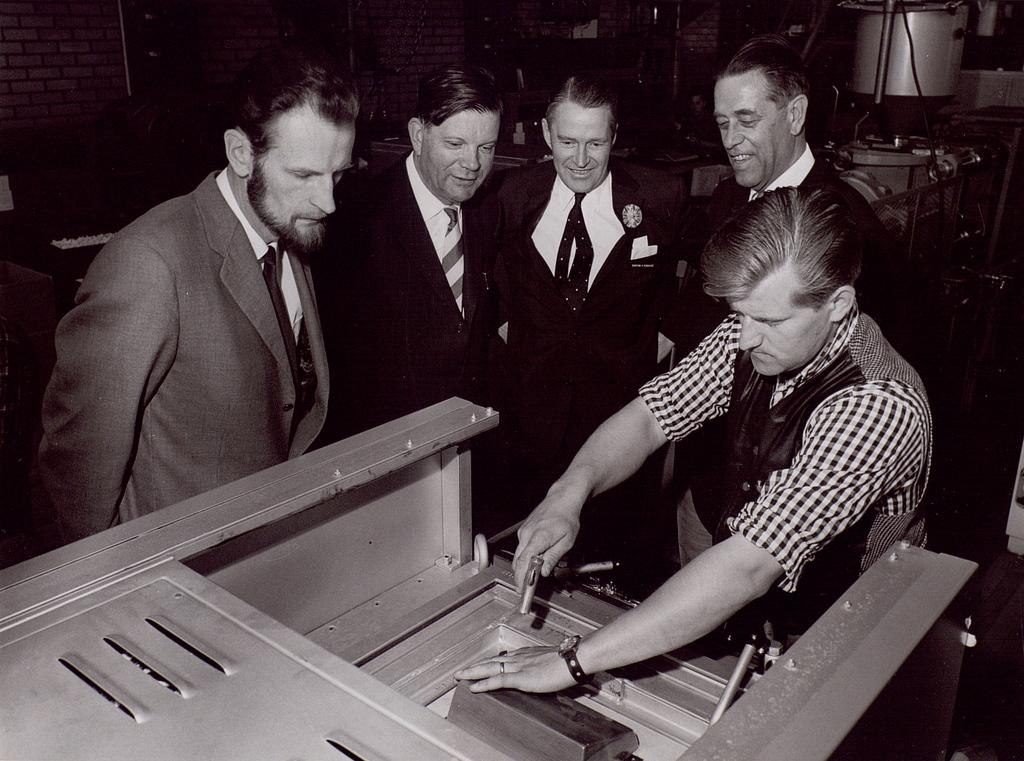What is located at the bottom of the image? There may be a machine at the bottom of the image. What is in front of the machine at the bottom of the image? There are people in front of the machine. What else can be seen on the right side of the image? There is another machine on the right side of the image, behind the people. What type of book is being read by the people in the image? There is no book present in the image; it features people in front of a machine. How many stockings are visible on the people in the image? There is no mention of stockings in the image; it only describes the presence of people and machines. 